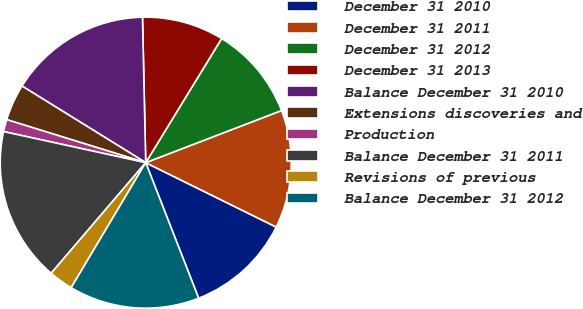Convert chart to OTSL. <chart><loc_0><loc_0><loc_500><loc_500><pie_chart><fcel>December 31 2010<fcel>December 31 2011<fcel>December 31 2012<fcel>December 31 2013<fcel>Balance December 31 2010<fcel>Extensions discoveries and<fcel>Production<fcel>Balance December 31 2011<fcel>Revisions of previous<fcel>Balance December 31 2012<nl><fcel>11.78%<fcel>13.13%<fcel>10.43%<fcel>9.09%<fcel>15.82%<fcel>4.05%<fcel>1.35%<fcel>17.17%<fcel>2.7%<fcel>14.48%<nl></chart> 